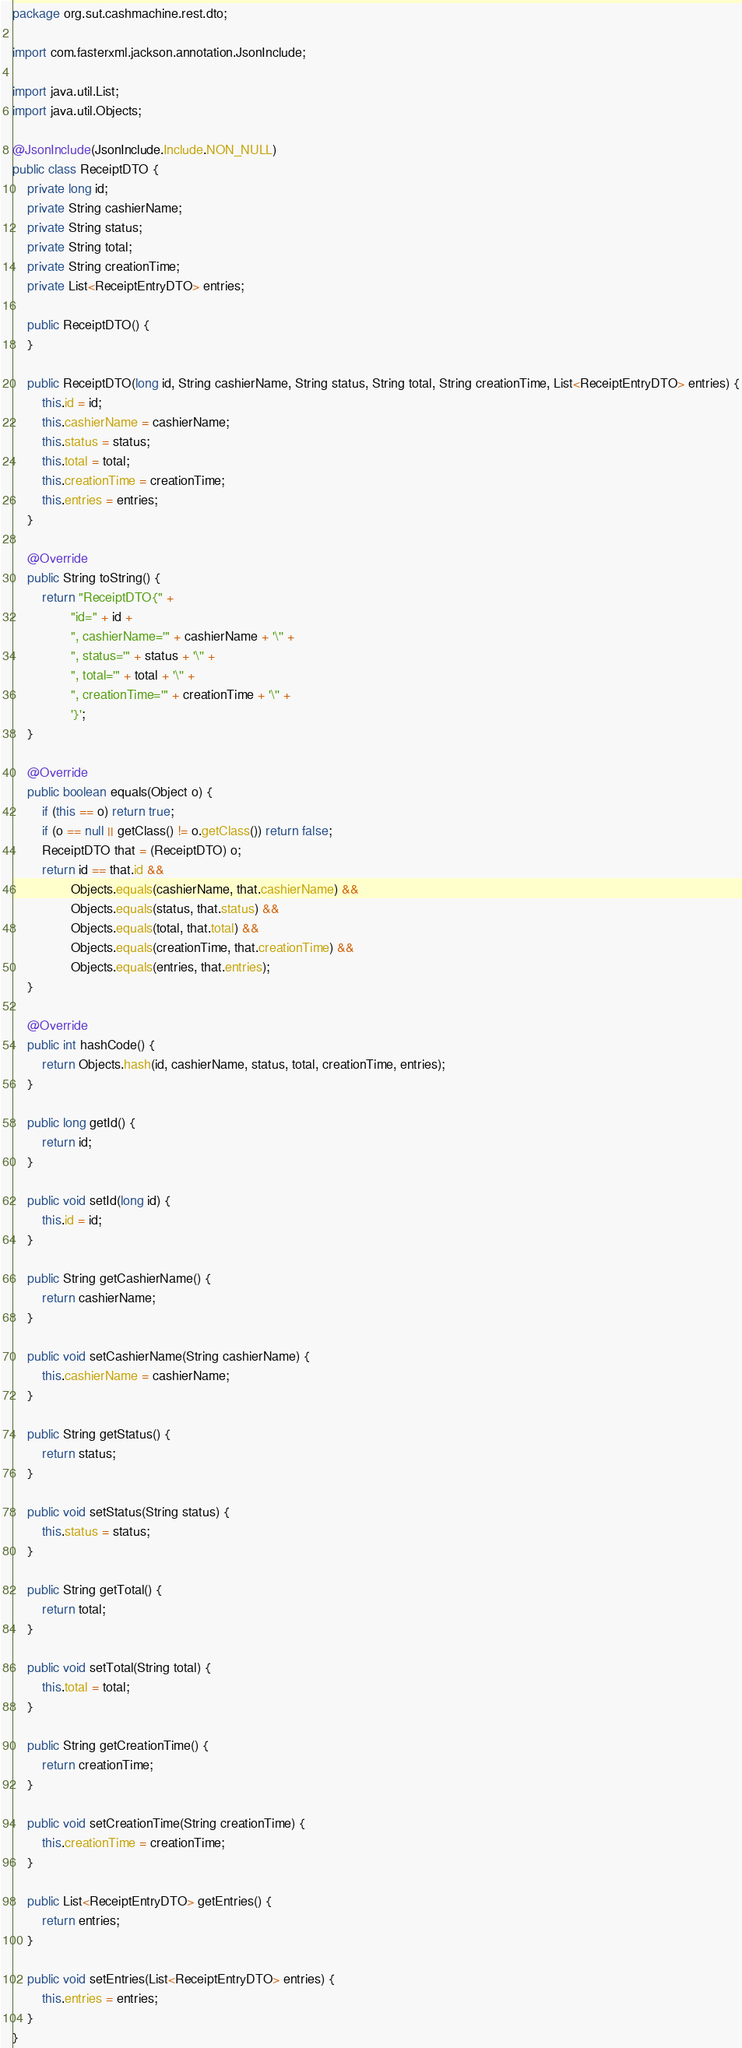Convert code to text. <code><loc_0><loc_0><loc_500><loc_500><_Java_>package org.sut.cashmachine.rest.dto;

import com.fasterxml.jackson.annotation.JsonInclude;

import java.util.List;
import java.util.Objects;

@JsonInclude(JsonInclude.Include.NON_NULL)
public class ReceiptDTO {
    private long id;
    private String cashierName;
    private String status;
    private String total;
    private String creationTime;
    private List<ReceiptEntryDTO> entries;

    public ReceiptDTO() {
    }

    public ReceiptDTO(long id, String cashierName, String status, String total, String creationTime, List<ReceiptEntryDTO> entries) {
        this.id = id;
        this.cashierName = cashierName;
        this.status = status;
        this.total = total;
        this.creationTime = creationTime;
        this.entries = entries;
    }

    @Override
    public String toString() {
        return "ReceiptDTO{" +
                "id=" + id +
                ", cashierName='" + cashierName + '\'' +
                ", status='" + status + '\'' +
                ", total='" + total + '\'' +
                ", creationTime='" + creationTime + '\'' +
                '}';
    }

    @Override
    public boolean equals(Object o) {
        if (this == o) return true;
        if (o == null || getClass() != o.getClass()) return false;
        ReceiptDTO that = (ReceiptDTO) o;
        return id == that.id &&
                Objects.equals(cashierName, that.cashierName) &&
                Objects.equals(status, that.status) &&
                Objects.equals(total, that.total) &&
                Objects.equals(creationTime, that.creationTime) &&
                Objects.equals(entries, that.entries);
    }

    @Override
    public int hashCode() {
        return Objects.hash(id, cashierName, status, total, creationTime, entries);
    }

    public long getId() {
        return id;
    }

    public void setId(long id) {
        this.id = id;
    }

    public String getCashierName() {
        return cashierName;
    }

    public void setCashierName(String cashierName) {
        this.cashierName = cashierName;
    }

    public String getStatus() {
        return status;
    }

    public void setStatus(String status) {
        this.status = status;
    }

    public String getTotal() {
        return total;
    }

    public void setTotal(String total) {
        this.total = total;
    }

    public String getCreationTime() {
        return creationTime;
    }

    public void setCreationTime(String creationTime) {
        this.creationTime = creationTime;
    }

    public List<ReceiptEntryDTO> getEntries() {
        return entries;
    }

    public void setEntries(List<ReceiptEntryDTO> entries) {
        this.entries = entries;
    }
}
</code> 